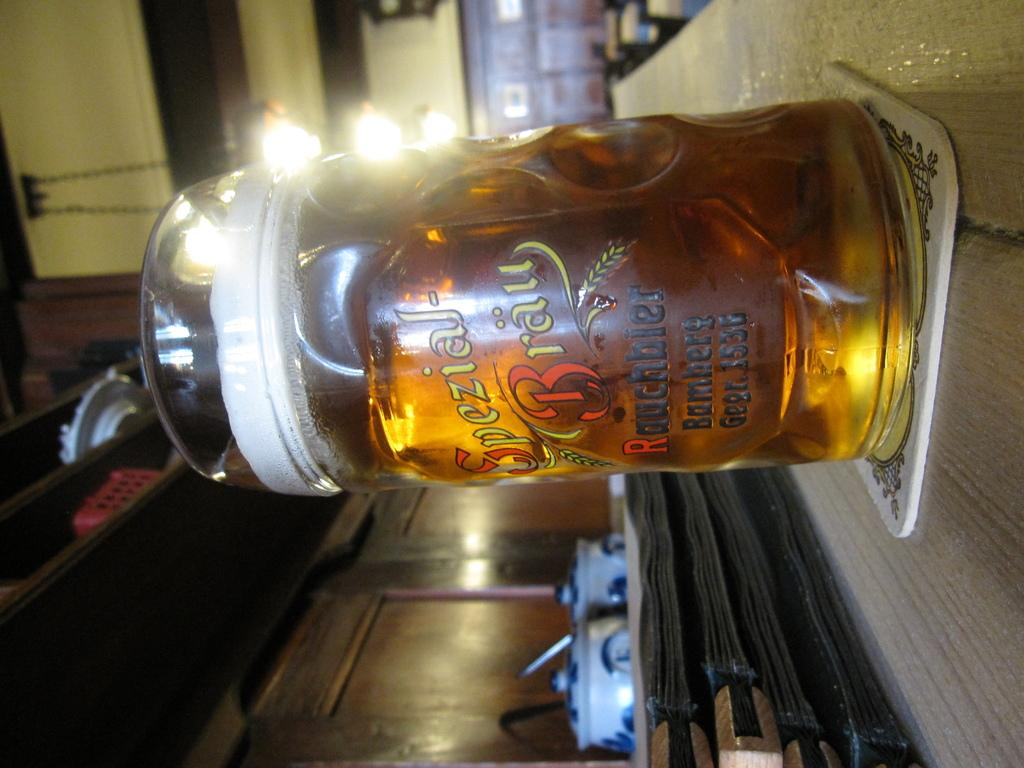<image>
Give a short and clear explanation of the subsequent image. A beer in a glass with the words special brew written in german 